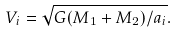<formula> <loc_0><loc_0><loc_500><loc_500>V _ { i } = \sqrt { G ( M _ { 1 } + M _ { 2 } ) / a _ { i } } .</formula> 